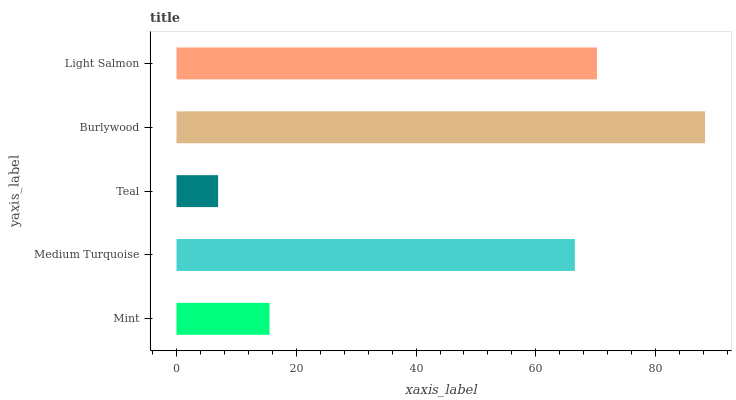Is Teal the minimum?
Answer yes or no. Yes. Is Burlywood the maximum?
Answer yes or no. Yes. Is Medium Turquoise the minimum?
Answer yes or no. No. Is Medium Turquoise the maximum?
Answer yes or no. No. Is Medium Turquoise greater than Mint?
Answer yes or no. Yes. Is Mint less than Medium Turquoise?
Answer yes or no. Yes. Is Mint greater than Medium Turquoise?
Answer yes or no. No. Is Medium Turquoise less than Mint?
Answer yes or no. No. Is Medium Turquoise the high median?
Answer yes or no. Yes. Is Medium Turquoise the low median?
Answer yes or no. Yes. Is Light Salmon the high median?
Answer yes or no. No. Is Teal the low median?
Answer yes or no. No. 